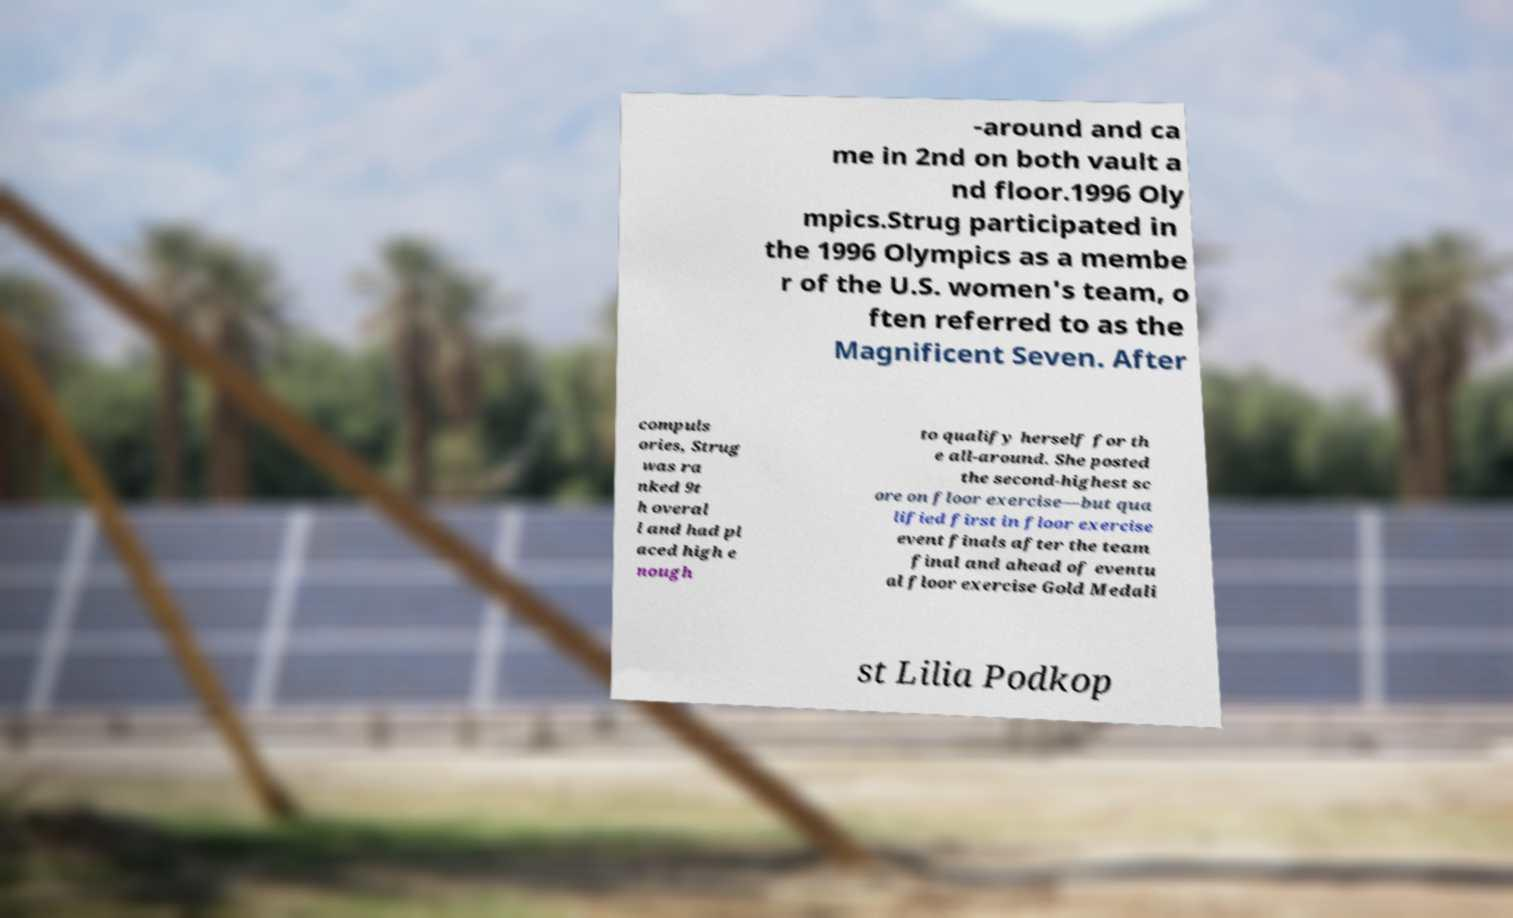For documentation purposes, I need the text within this image transcribed. Could you provide that? -around and ca me in 2nd on both vault a nd floor.1996 Oly mpics.Strug participated in the 1996 Olympics as a membe r of the U.S. women's team, o ften referred to as the Magnificent Seven. After compuls ories, Strug was ra nked 9t h overal l and had pl aced high e nough to qualify herself for th e all-around. She posted the second-highest sc ore on floor exercise—but qua lified first in floor exercise event finals after the team final and ahead of eventu al floor exercise Gold Medali st Lilia Podkop 